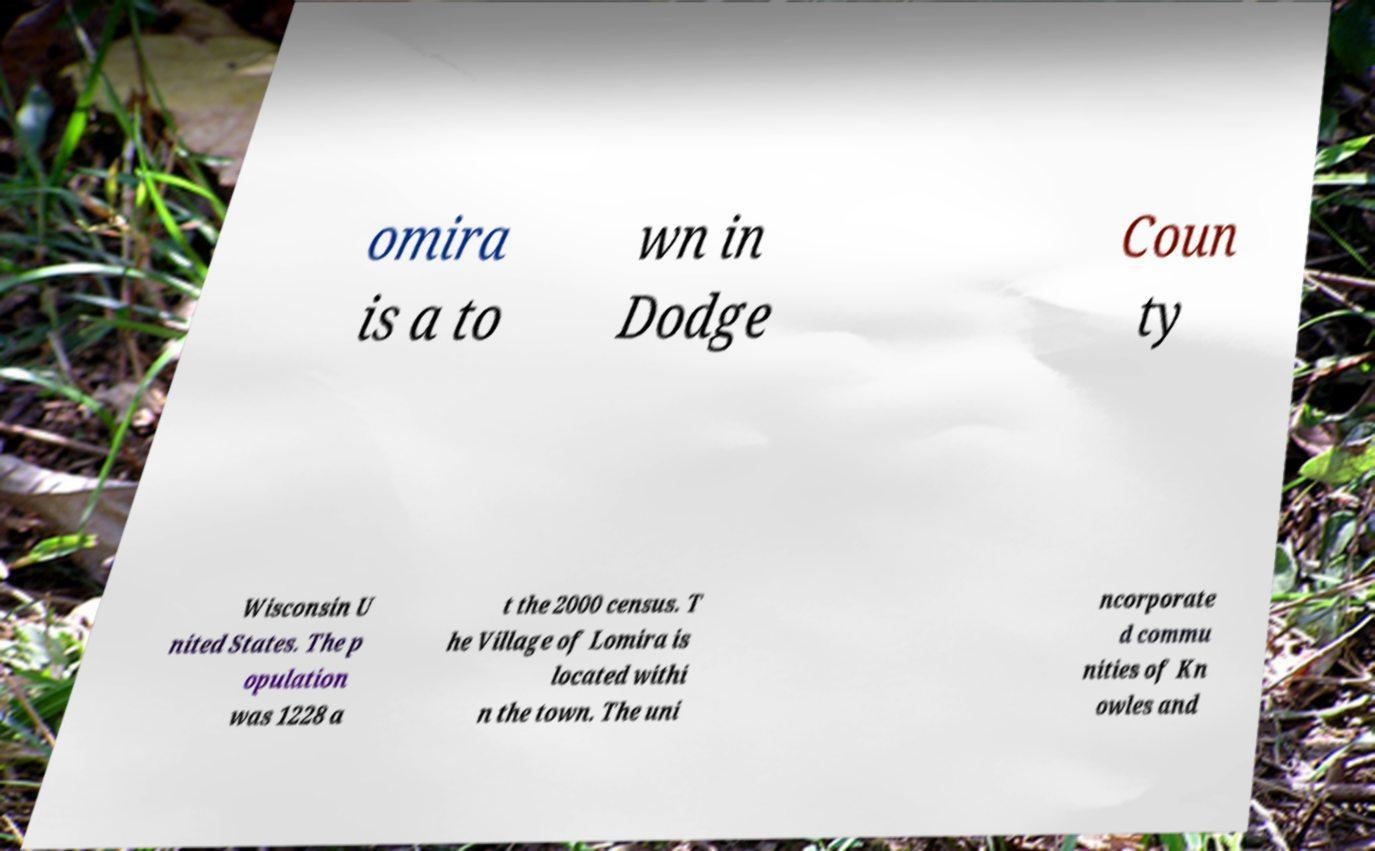There's text embedded in this image that I need extracted. Can you transcribe it verbatim? omira is a to wn in Dodge Coun ty Wisconsin U nited States. The p opulation was 1228 a t the 2000 census. T he Village of Lomira is located withi n the town. The uni ncorporate d commu nities of Kn owles and 